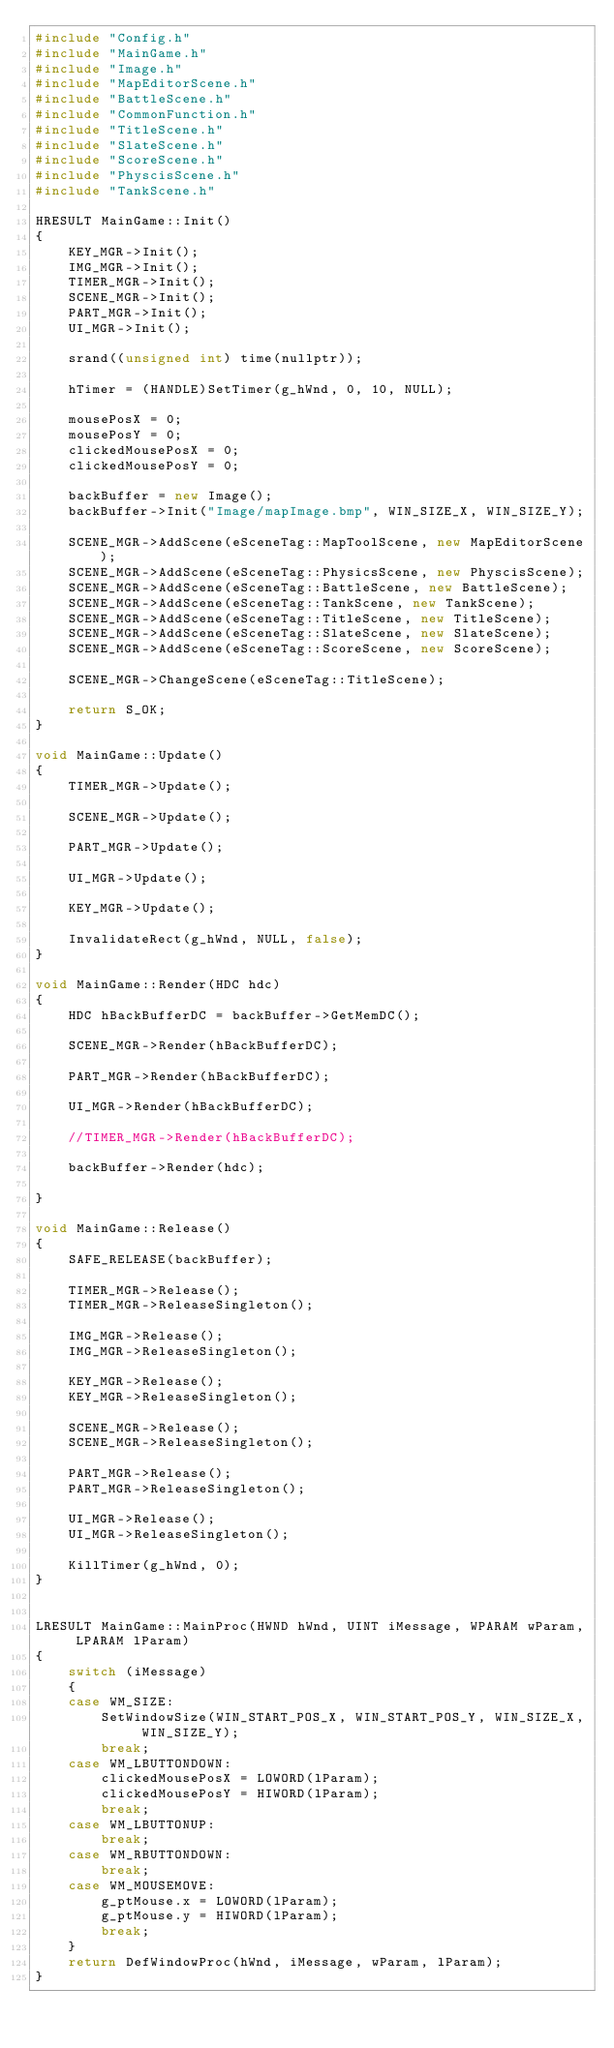<code> <loc_0><loc_0><loc_500><loc_500><_C++_>#include "Config.h"
#include "MainGame.h"
#include "Image.h"
#include "MapEditorScene.h"
#include "BattleScene.h"
#include "CommonFunction.h"
#include "TitleScene.h"
#include "SlateScene.h"
#include "ScoreScene.h"
#include "PhyscisScene.h"
#include "TankScene.h"

HRESULT MainGame::Init()
{
	KEY_MGR->Init();
	IMG_MGR->Init();
	TIMER_MGR->Init();
	SCENE_MGR->Init();
	PART_MGR->Init();
	UI_MGR->Init();

	srand((unsigned int) time(nullptr));

	hTimer = (HANDLE)SetTimer(g_hWnd, 0, 10, NULL);

	mousePosX = 0;
	mousePosY = 0;
	clickedMousePosX = 0; 
	clickedMousePosY = 0; 

	backBuffer = new Image();
	backBuffer->Init("Image/mapImage.bmp", WIN_SIZE_X, WIN_SIZE_Y);

	SCENE_MGR->AddScene(eSceneTag::MapToolScene, new MapEditorScene);
	SCENE_MGR->AddScene(eSceneTag::PhysicsScene, new PhyscisScene);
	SCENE_MGR->AddScene(eSceneTag::BattleScene, new BattleScene);
	SCENE_MGR->AddScene(eSceneTag::TankScene, new TankScene);
	SCENE_MGR->AddScene(eSceneTag::TitleScene, new TitleScene);
	SCENE_MGR->AddScene(eSceneTag::SlateScene, new SlateScene);
	SCENE_MGR->AddScene(eSceneTag::ScoreScene, new ScoreScene);
	
	SCENE_MGR->ChangeScene(eSceneTag::TitleScene);

	return S_OK;
}

void MainGame::Update()
{
	TIMER_MGR->Update();
	
	SCENE_MGR->Update();

	PART_MGR->Update();

	UI_MGR->Update();
	
	KEY_MGR->Update();

	InvalidateRect(g_hWnd, NULL, false);
}

void MainGame::Render(HDC hdc)
{
	HDC hBackBufferDC = backBuffer->GetMemDC();
	
	SCENE_MGR->Render(hBackBufferDC);

	PART_MGR->Render(hBackBufferDC);

	UI_MGR->Render(hBackBufferDC);
	
	//TIMER_MGR->Render(hBackBufferDC);
	
	backBuffer->Render(hdc);

}

void MainGame::Release()
{
	SAFE_RELEASE(backBuffer);

	TIMER_MGR->Release();
	TIMER_MGR->ReleaseSingleton();
	
	IMG_MGR->Release();
	IMG_MGR->ReleaseSingleton();

	KEY_MGR->Release();
	KEY_MGR->ReleaseSingleton();

	SCENE_MGR->Release();
	SCENE_MGR->ReleaseSingleton();

	PART_MGR->Release();
	PART_MGR->ReleaseSingleton();

	UI_MGR->Release();
	UI_MGR->ReleaseSingleton();

	KillTimer(g_hWnd, 0);
}


LRESULT MainGame::MainProc(HWND hWnd, UINT iMessage, WPARAM wParam, LPARAM lParam)
{
	switch (iMessage)
	{
	case WM_SIZE:
		SetWindowSize(WIN_START_POS_X, WIN_START_POS_Y, WIN_SIZE_X, WIN_SIZE_Y);
		break;
	case WM_LBUTTONDOWN:
		clickedMousePosX = LOWORD(lParam);
		clickedMousePosY = HIWORD(lParam);
		break;
	case WM_LBUTTONUP:
		break;
	case WM_RBUTTONDOWN:
		break;
	case WM_MOUSEMOVE:
		g_ptMouse.x = LOWORD(lParam);
		g_ptMouse.y = HIWORD(lParam);
		break;
	}
	return DefWindowProc(hWnd, iMessage, wParam, lParam);
}
</code> 